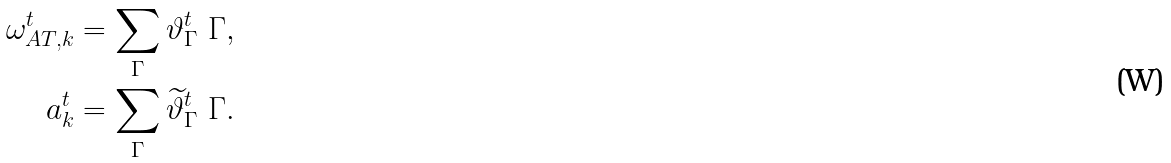<formula> <loc_0><loc_0><loc_500><loc_500>\omega ^ { t } _ { A T , k } & = \sum _ { \Gamma } \vartheta ^ { t } _ { \Gamma } \ \Gamma , \\ a ^ { t } _ { k } & = \sum _ { \Gamma } \widetilde { \vartheta } ^ { t } _ { \Gamma } \ \Gamma .</formula> 